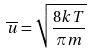Convert formula to latex. <formula><loc_0><loc_0><loc_500><loc_500>\overline { u } = \sqrt { \frac { 8 k T } { \pi m } }</formula> 